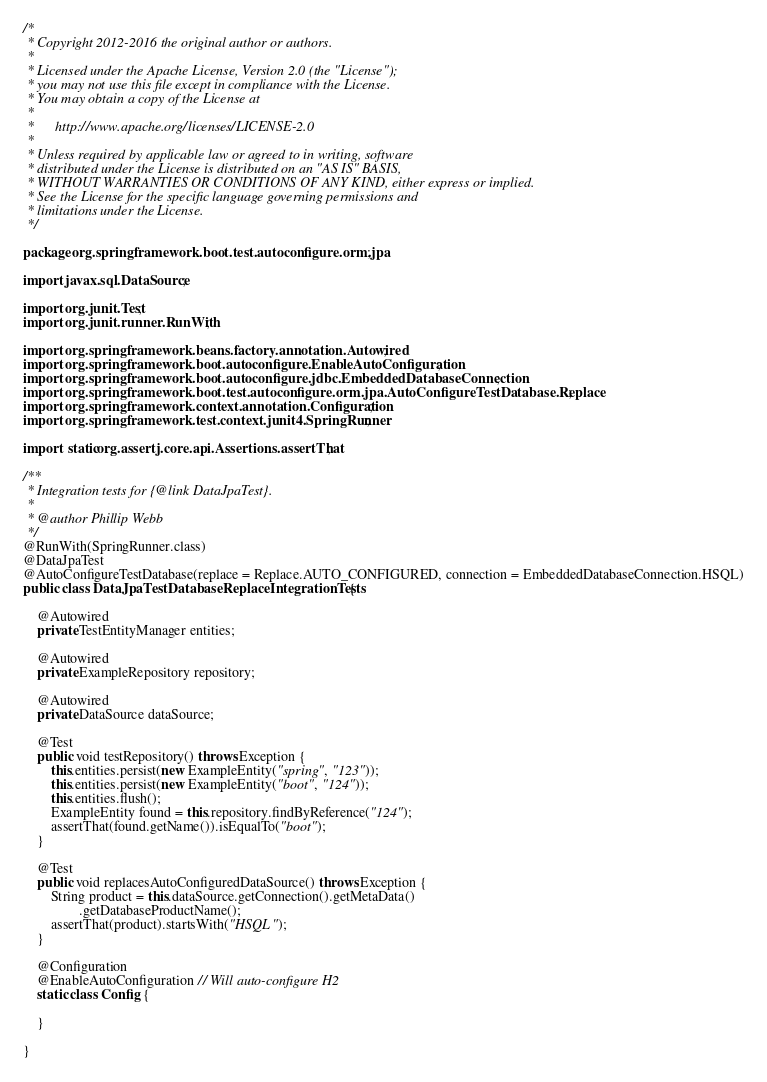Convert code to text. <code><loc_0><loc_0><loc_500><loc_500><_Java_>/*
 * Copyright 2012-2016 the original author or authors.
 *
 * Licensed under the Apache License, Version 2.0 (the "License");
 * you may not use this file except in compliance with the License.
 * You may obtain a copy of the License at
 *
 *      http://www.apache.org/licenses/LICENSE-2.0
 *
 * Unless required by applicable law or agreed to in writing, software
 * distributed under the License is distributed on an "AS IS" BASIS,
 * WITHOUT WARRANTIES OR CONDITIONS OF ANY KIND, either express or implied.
 * See the License for the specific language governing permissions and
 * limitations under the License.
 */

package org.springframework.boot.test.autoconfigure.orm.jpa;

import javax.sql.DataSource;

import org.junit.Test;
import org.junit.runner.RunWith;

import org.springframework.beans.factory.annotation.Autowired;
import org.springframework.boot.autoconfigure.EnableAutoConfiguration;
import org.springframework.boot.autoconfigure.jdbc.EmbeddedDatabaseConnection;
import org.springframework.boot.test.autoconfigure.orm.jpa.AutoConfigureTestDatabase.Replace;
import org.springframework.context.annotation.Configuration;
import org.springframework.test.context.junit4.SpringRunner;

import static org.assertj.core.api.Assertions.assertThat;

/**
 * Integration tests for {@link DataJpaTest}.
 *
 * @author Phillip Webb
 */
@RunWith(SpringRunner.class)
@DataJpaTest
@AutoConfigureTestDatabase(replace = Replace.AUTO_CONFIGURED, connection = EmbeddedDatabaseConnection.HSQL)
public class DataJpaTestDatabaseReplaceIntegrationTests {

	@Autowired
	private TestEntityManager entities;

	@Autowired
	private ExampleRepository repository;

	@Autowired
	private DataSource dataSource;

	@Test
	public void testRepository() throws Exception {
		this.entities.persist(new ExampleEntity("spring", "123"));
		this.entities.persist(new ExampleEntity("boot", "124"));
		this.entities.flush();
		ExampleEntity found = this.repository.findByReference("124");
		assertThat(found.getName()).isEqualTo("boot");
	}

	@Test
	public void replacesAutoConfiguredDataSource() throws Exception {
		String product = this.dataSource.getConnection().getMetaData()
				.getDatabaseProductName();
		assertThat(product).startsWith("HSQL");
	}

	@Configuration
	@EnableAutoConfiguration // Will auto-configure H2
	static class Config {

	}

}
</code> 